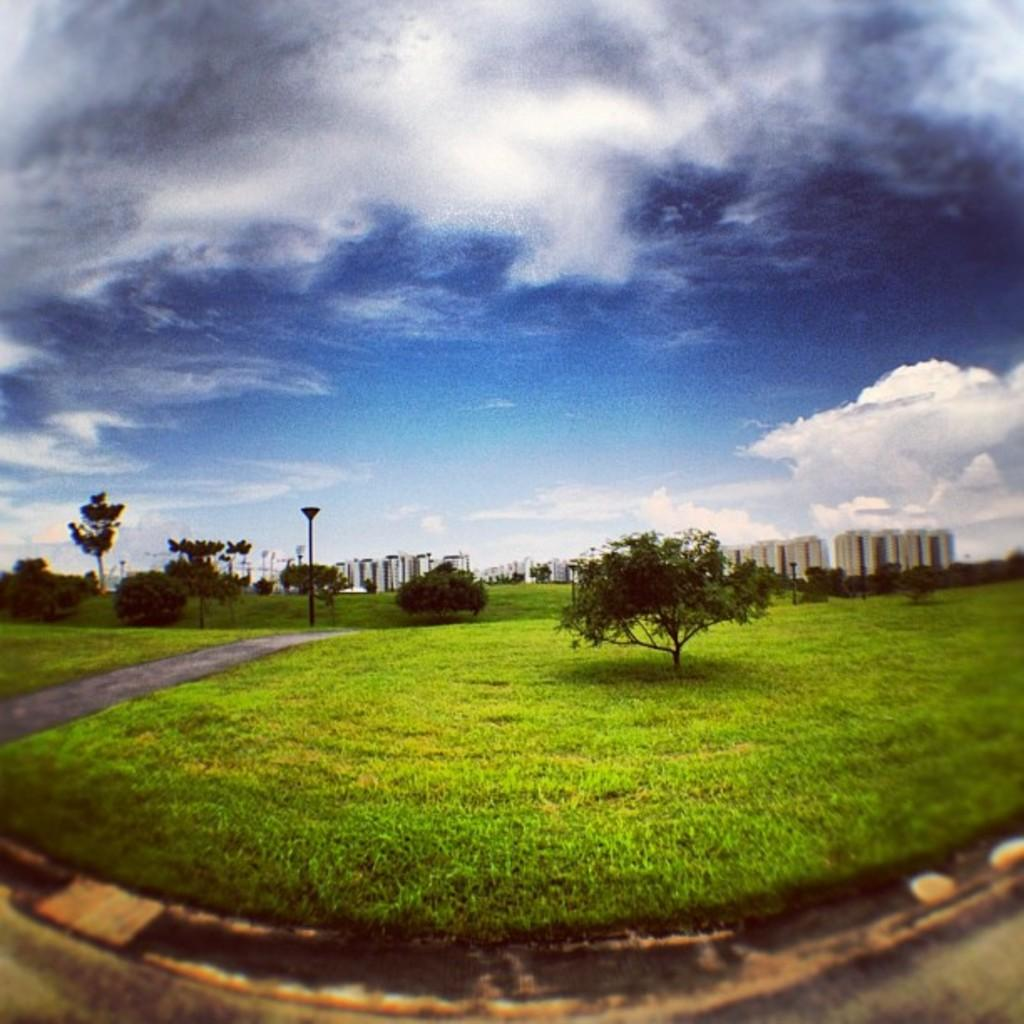What type of vegetation is present on the ground in the front of the image? There is grass on the ground in the front of the image. What can be seen in the center of the image? There is a tree in the center of the image. What is visible in the background of the image? There are poles, trees, and buildings in the background of the image. What is the condition of the sky in the image? The sky is cloudy in the image. What type of watch can be seen hanging from the tree in the image? There is no watch present in the image; it features a tree, grass, and various background elements. What color is the thread used to sew the card in the image? There is no card or thread present in the image. 